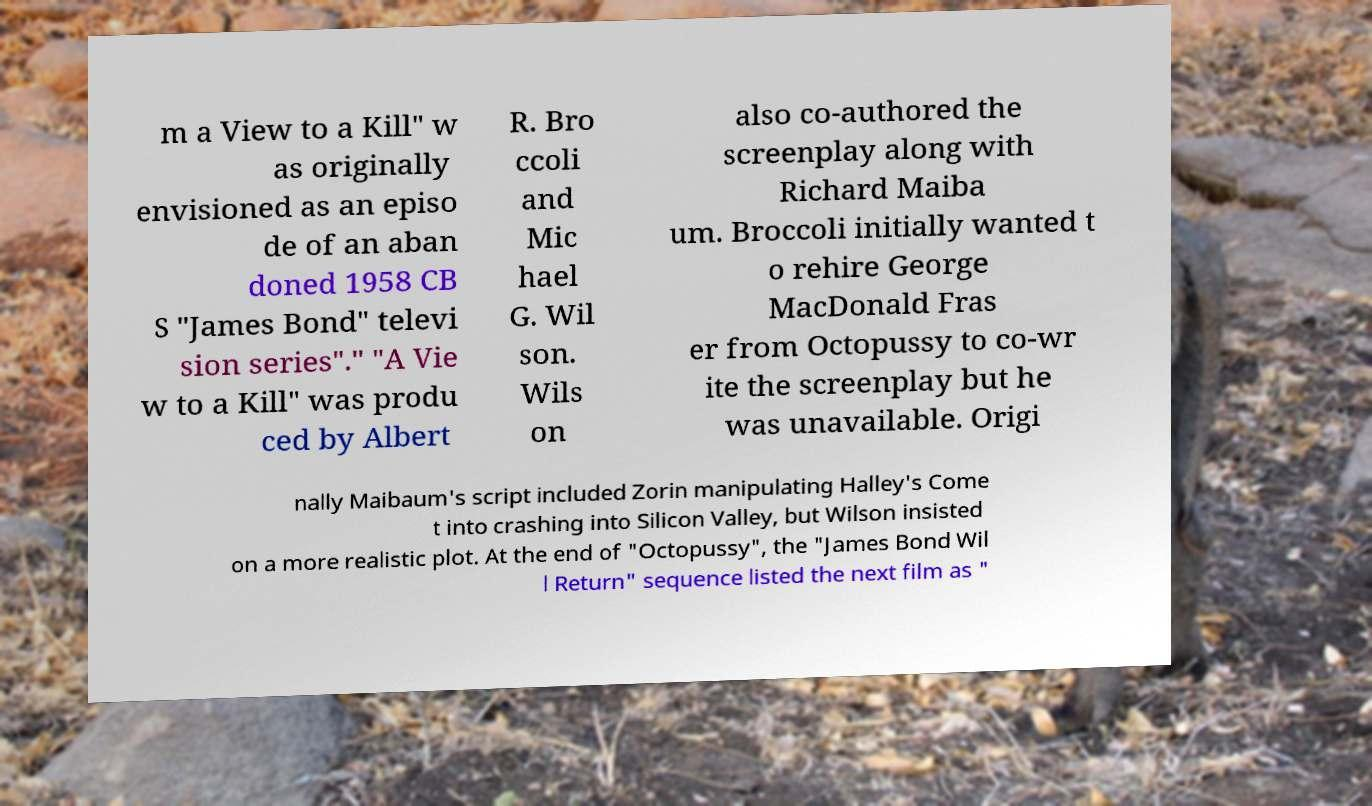Please read and relay the text visible in this image. What does it say? m a View to a Kill" w as originally envisioned as an episo de of an aban doned 1958 CB S "James Bond" televi sion series"." "A Vie w to a Kill" was produ ced by Albert R. Bro ccoli and Mic hael G. Wil son. Wils on also co-authored the screenplay along with Richard Maiba um. Broccoli initially wanted t o rehire George MacDonald Fras er from Octopussy to co-wr ite the screenplay but he was unavailable. Origi nally Maibaum's script included Zorin manipulating Halley's Come t into crashing into Silicon Valley, but Wilson insisted on a more realistic plot. At the end of "Octopussy", the "James Bond Wil l Return" sequence listed the next film as " 